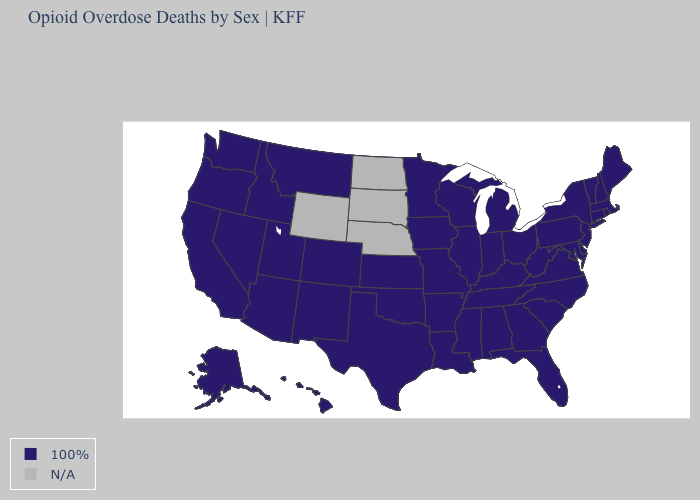What is the value of Texas?
Concise answer only. 100%. Which states have the lowest value in the MidWest?
Write a very short answer. Illinois, Indiana, Iowa, Kansas, Michigan, Minnesota, Missouri, Ohio, Wisconsin. Name the states that have a value in the range 100%?
Answer briefly. Alabama, Alaska, Arizona, Arkansas, California, Colorado, Connecticut, Delaware, Florida, Georgia, Hawaii, Idaho, Illinois, Indiana, Iowa, Kansas, Kentucky, Louisiana, Maine, Maryland, Massachusetts, Michigan, Minnesota, Mississippi, Missouri, Montana, Nevada, New Hampshire, New Jersey, New Mexico, New York, North Carolina, Ohio, Oklahoma, Oregon, Pennsylvania, Rhode Island, South Carolina, Tennessee, Texas, Utah, Vermont, Virginia, Washington, West Virginia, Wisconsin. Name the states that have a value in the range 100%?
Concise answer only. Alabama, Alaska, Arizona, Arkansas, California, Colorado, Connecticut, Delaware, Florida, Georgia, Hawaii, Idaho, Illinois, Indiana, Iowa, Kansas, Kentucky, Louisiana, Maine, Maryland, Massachusetts, Michigan, Minnesota, Mississippi, Missouri, Montana, Nevada, New Hampshire, New Jersey, New Mexico, New York, North Carolina, Ohio, Oklahoma, Oregon, Pennsylvania, Rhode Island, South Carolina, Tennessee, Texas, Utah, Vermont, Virginia, Washington, West Virginia, Wisconsin. Name the states that have a value in the range N/A?
Give a very brief answer. Nebraska, North Dakota, South Dakota, Wyoming. What is the highest value in the USA?
Short answer required. 100%. Which states have the lowest value in the Northeast?
Keep it brief. Connecticut, Maine, Massachusetts, New Hampshire, New Jersey, New York, Pennsylvania, Rhode Island, Vermont. Name the states that have a value in the range N/A?
Write a very short answer. Nebraska, North Dakota, South Dakota, Wyoming. Name the states that have a value in the range 100%?
Answer briefly. Alabama, Alaska, Arizona, Arkansas, California, Colorado, Connecticut, Delaware, Florida, Georgia, Hawaii, Idaho, Illinois, Indiana, Iowa, Kansas, Kentucky, Louisiana, Maine, Maryland, Massachusetts, Michigan, Minnesota, Mississippi, Missouri, Montana, Nevada, New Hampshire, New Jersey, New Mexico, New York, North Carolina, Ohio, Oklahoma, Oregon, Pennsylvania, Rhode Island, South Carolina, Tennessee, Texas, Utah, Vermont, Virginia, Washington, West Virginia, Wisconsin. What is the value of Montana?
Answer briefly. 100%. What is the value of Colorado?
Quick response, please. 100%. What is the highest value in the South ?
Concise answer only. 100%. Name the states that have a value in the range N/A?
Short answer required. Nebraska, North Dakota, South Dakota, Wyoming. What is the value of Maine?
Short answer required. 100%. 